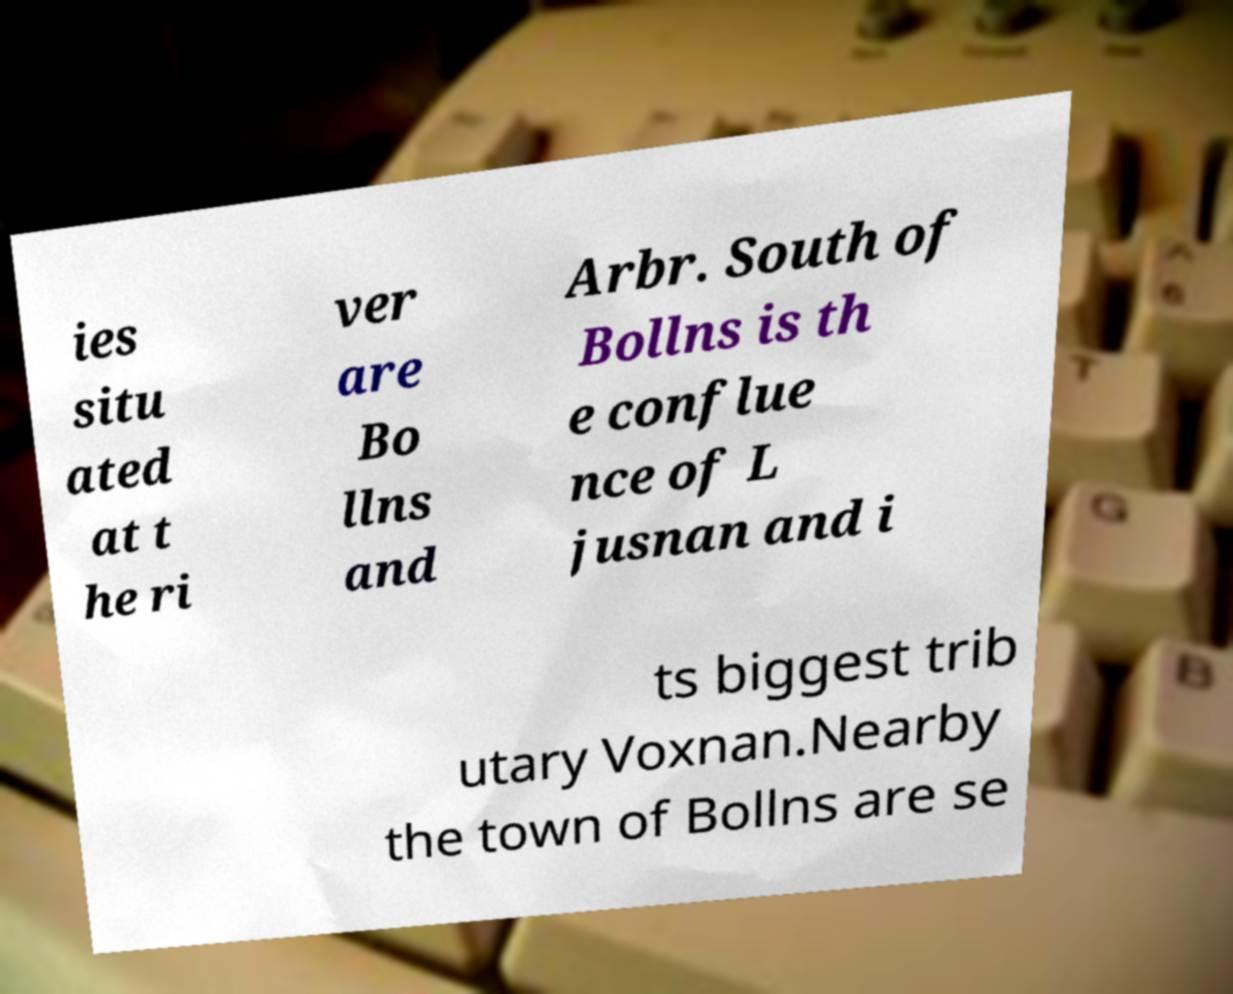Could you extract and type out the text from this image? ies situ ated at t he ri ver are Bo llns and Arbr. South of Bollns is th e conflue nce of L jusnan and i ts biggest trib utary Voxnan.Nearby the town of Bollns are se 